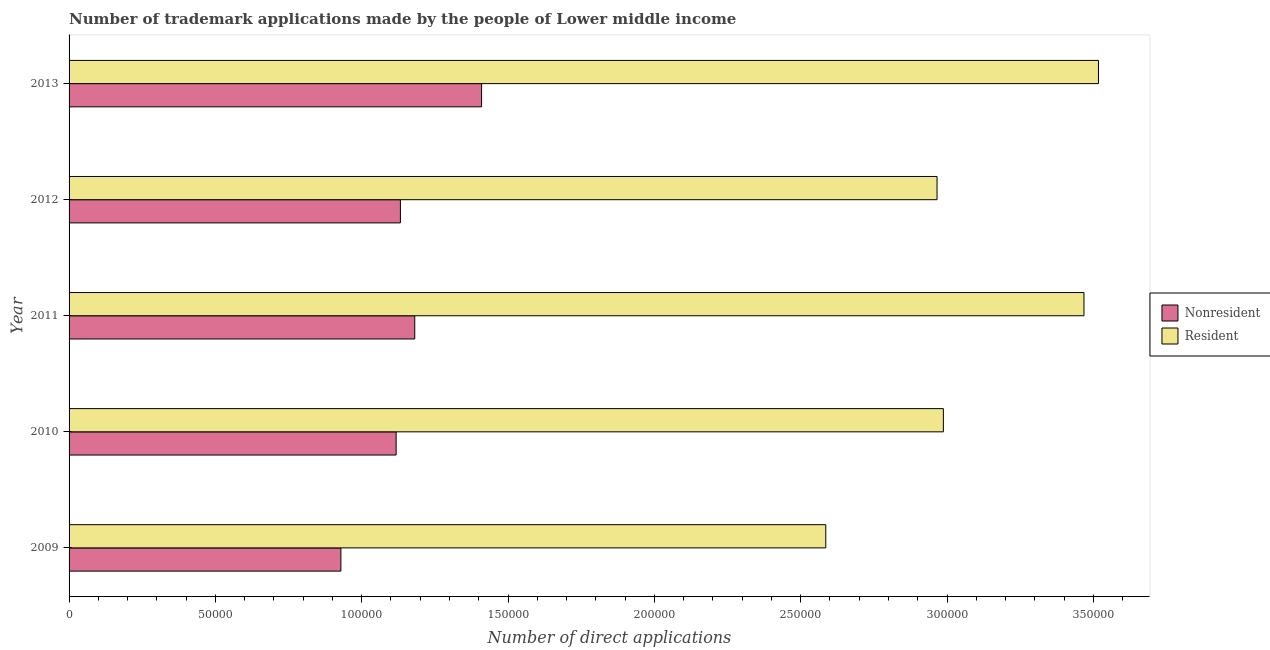How many different coloured bars are there?
Offer a very short reply. 2. Are the number of bars per tick equal to the number of legend labels?
Provide a short and direct response. Yes. Are the number of bars on each tick of the Y-axis equal?
Provide a succinct answer. Yes. How many bars are there on the 3rd tick from the top?
Give a very brief answer. 2. How many bars are there on the 2nd tick from the bottom?
Your answer should be very brief. 2. What is the label of the 4th group of bars from the top?
Keep it short and to the point. 2010. In how many cases, is the number of bars for a given year not equal to the number of legend labels?
Make the answer very short. 0. What is the number of trademark applications made by residents in 2013?
Your answer should be compact. 3.52e+05. Across all years, what is the maximum number of trademark applications made by non residents?
Ensure brevity in your answer.  1.41e+05. Across all years, what is the minimum number of trademark applications made by residents?
Your answer should be compact. 2.59e+05. In which year was the number of trademark applications made by non residents maximum?
Make the answer very short. 2013. What is the total number of trademark applications made by residents in the graph?
Your response must be concise. 1.55e+06. What is the difference between the number of trademark applications made by non residents in 2010 and that in 2012?
Offer a very short reply. -1458. What is the difference between the number of trademark applications made by non residents in 2009 and the number of trademark applications made by residents in 2010?
Offer a very short reply. -2.06e+05. What is the average number of trademark applications made by residents per year?
Keep it short and to the point. 3.10e+05. In the year 2010, what is the difference between the number of trademark applications made by residents and number of trademark applications made by non residents?
Ensure brevity in your answer.  1.87e+05. In how many years, is the number of trademark applications made by residents greater than 280000 ?
Your response must be concise. 4. What is the ratio of the number of trademark applications made by residents in 2009 to that in 2011?
Your answer should be compact. 0.75. Is the number of trademark applications made by residents in 2009 less than that in 2011?
Give a very brief answer. Yes. Is the difference between the number of trademark applications made by non residents in 2010 and 2012 greater than the difference between the number of trademark applications made by residents in 2010 and 2012?
Your answer should be very brief. No. What is the difference between the highest and the second highest number of trademark applications made by residents?
Your answer should be compact. 4956. What is the difference between the highest and the lowest number of trademark applications made by non residents?
Your response must be concise. 4.81e+04. In how many years, is the number of trademark applications made by non residents greater than the average number of trademark applications made by non residents taken over all years?
Your response must be concise. 2. Is the sum of the number of trademark applications made by non residents in 2009 and 2011 greater than the maximum number of trademark applications made by residents across all years?
Your answer should be very brief. No. What does the 1st bar from the top in 2010 represents?
Your answer should be very brief. Resident. What does the 2nd bar from the bottom in 2011 represents?
Your answer should be very brief. Resident. How many bars are there?
Make the answer very short. 10. Are all the bars in the graph horizontal?
Offer a terse response. Yes. How many years are there in the graph?
Give a very brief answer. 5. How are the legend labels stacked?
Make the answer very short. Vertical. What is the title of the graph?
Ensure brevity in your answer.  Number of trademark applications made by the people of Lower middle income. Does "Ages 15-24" appear as one of the legend labels in the graph?
Provide a short and direct response. No. What is the label or title of the X-axis?
Offer a very short reply. Number of direct applications. What is the Number of direct applications in Nonresident in 2009?
Offer a very short reply. 9.29e+04. What is the Number of direct applications of Resident in 2009?
Offer a terse response. 2.59e+05. What is the Number of direct applications of Nonresident in 2010?
Your answer should be compact. 1.12e+05. What is the Number of direct applications of Resident in 2010?
Offer a terse response. 2.99e+05. What is the Number of direct applications in Nonresident in 2011?
Keep it short and to the point. 1.18e+05. What is the Number of direct applications of Resident in 2011?
Keep it short and to the point. 3.47e+05. What is the Number of direct applications in Nonresident in 2012?
Provide a short and direct response. 1.13e+05. What is the Number of direct applications of Resident in 2012?
Ensure brevity in your answer.  2.97e+05. What is the Number of direct applications of Nonresident in 2013?
Offer a terse response. 1.41e+05. What is the Number of direct applications in Resident in 2013?
Offer a very short reply. 3.52e+05. Across all years, what is the maximum Number of direct applications of Nonresident?
Keep it short and to the point. 1.41e+05. Across all years, what is the maximum Number of direct applications in Resident?
Your answer should be compact. 3.52e+05. Across all years, what is the minimum Number of direct applications in Nonresident?
Keep it short and to the point. 9.29e+04. Across all years, what is the minimum Number of direct applications of Resident?
Provide a succinct answer. 2.59e+05. What is the total Number of direct applications of Nonresident in the graph?
Your response must be concise. 5.77e+05. What is the total Number of direct applications in Resident in the graph?
Ensure brevity in your answer.  1.55e+06. What is the difference between the Number of direct applications of Nonresident in 2009 and that in 2010?
Offer a terse response. -1.89e+04. What is the difference between the Number of direct applications in Resident in 2009 and that in 2010?
Offer a terse response. -4.02e+04. What is the difference between the Number of direct applications in Nonresident in 2009 and that in 2011?
Ensure brevity in your answer.  -2.52e+04. What is the difference between the Number of direct applications in Resident in 2009 and that in 2011?
Provide a succinct answer. -8.82e+04. What is the difference between the Number of direct applications of Nonresident in 2009 and that in 2012?
Your answer should be compact. -2.03e+04. What is the difference between the Number of direct applications of Resident in 2009 and that in 2012?
Make the answer very short. -3.80e+04. What is the difference between the Number of direct applications of Nonresident in 2009 and that in 2013?
Give a very brief answer. -4.81e+04. What is the difference between the Number of direct applications of Resident in 2009 and that in 2013?
Keep it short and to the point. -9.32e+04. What is the difference between the Number of direct applications of Nonresident in 2010 and that in 2011?
Make the answer very short. -6363. What is the difference between the Number of direct applications in Resident in 2010 and that in 2011?
Make the answer very short. -4.80e+04. What is the difference between the Number of direct applications of Nonresident in 2010 and that in 2012?
Give a very brief answer. -1458. What is the difference between the Number of direct applications of Resident in 2010 and that in 2012?
Provide a succinct answer. 2166. What is the difference between the Number of direct applications of Nonresident in 2010 and that in 2013?
Offer a terse response. -2.92e+04. What is the difference between the Number of direct applications of Resident in 2010 and that in 2013?
Keep it short and to the point. -5.30e+04. What is the difference between the Number of direct applications of Nonresident in 2011 and that in 2012?
Your response must be concise. 4905. What is the difference between the Number of direct applications in Resident in 2011 and that in 2012?
Offer a terse response. 5.02e+04. What is the difference between the Number of direct applications in Nonresident in 2011 and that in 2013?
Offer a very short reply. -2.28e+04. What is the difference between the Number of direct applications in Resident in 2011 and that in 2013?
Provide a succinct answer. -4956. What is the difference between the Number of direct applications of Nonresident in 2012 and that in 2013?
Give a very brief answer. -2.77e+04. What is the difference between the Number of direct applications of Resident in 2012 and that in 2013?
Keep it short and to the point. -5.52e+04. What is the difference between the Number of direct applications of Nonresident in 2009 and the Number of direct applications of Resident in 2010?
Make the answer very short. -2.06e+05. What is the difference between the Number of direct applications of Nonresident in 2009 and the Number of direct applications of Resident in 2011?
Give a very brief answer. -2.54e+05. What is the difference between the Number of direct applications of Nonresident in 2009 and the Number of direct applications of Resident in 2012?
Offer a very short reply. -2.04e+05. What is the difference between the Number of direct applications of Nonresident in 2009 and the Number of direct applications of Resident in 2013?
Make the answer very short. -2.59e+05. What is the difference between the Number of direct applications in Nonresident in 2010 and the Number of direct applications in Resident in 2011?
Keep it short and to the point. -2.35e+05. What is the difference between the Number of direct applications of Nonresident in 2010 and the Number of direct applications of Resident in 2012?
Provide a succinct answer. -1.85e+05. What is the difference between the Number of direct applications in Nonresident in 2010 and the Number of direct applications in Resident in 2013?
Provide a short and direct response. -2.40e+05. What is the difference between the Number of direct applications in Nonresident in 2011 and the Number of direct applications in Resident in 2012?
Your answer should be very brief. -1.78e+05. What is the difference between the Number of direct applications of Nonresident in 2011 and the Number of direct applications of Resident in 2013?
Make the answer very short. -2.34e+05. What is the difference between the Number of direct applications in Nonresident in 2012 and the Number of direct applications in Resident in 2013?
Ensure brevity in your answer.  -2.39e+05. What is the average Number of direct applications in Nonresident per year?
Give a very brief answer. 1.15e+05. What is the average Number of direct applications of Resident per year?
Ensure brevity in your answer.  3.10e+05. In the year 2009, what is the difference between the Number of direct applications of Nonresident and Number of direct applications of Resident?
Your answer should be compact. -1.66e+05. In the year 2010, what is the difference between the Number of direct applications of Nonresident and Number of direct applications of Resident?
Your answer should be compact. -1.87e+05. In the year 2011, what is the difference between the Number of direct applications in Nonresident and Number of direct applications in Resident?
Make the answer very short. -2.29e+05. In the year 2012, what is the difference between the Number of direct applications in Nonresident and Number of direct applications in Resident?
Ensure brevity in your answer.  -1.83e+05. In the year 2013, what is the difference between the Number of direct applications of Nonresident and Number of direct applications of Resident?
Provide a succinct answer. -2.11e+05. What is the ratio of the Number of direct applications of Nonresident in 2009 to that in 2010?
Make the answer very short. 0.83. What is the ratio of the Number of direct applications in Resident in 2009 to that in 2010?
Provide a short and direct response. 0.87. What is the ratio of the Number of direct applications in Nonresident in 2009 to that in 2011?
Your answer should be very brief. 0.79. What is the ratio of the Number of direct applications in Resident in 2009 to that in 2011?
Your answer should be compact. 0.75. What is the ratio of the Number of direct applications in Nonresident in 2009 to that in 2012?
Offer a very short reply. 0.82. What is the ratio of the Number of direct applications of Resident in 2009 to that in 2012?
Give a very brief answer. 0.87. What is the ratio of the Number of direct applications of Nonresident in 2009 to that in 2013?
Offer a terse response. 0.66. What is the ratio of the Number of direct applications in Resident in 2009 to that in 2013?
Provide a short and direct response. 0.74. What is the ratio of the Number of direct applications of Nonresident in 2010 to that in 2011?
Ensure brevity in your answer.  0.95. What is the ratio of the Number of direct applications of Resident in 2010 to that in 2011?
Provide a short and direct response. 0.86. What is the ratio of the Number of direct applications in Nonresident in 2010 to that in 2012?
Offer a very short reply. 0.99. What is the ratio of the Number of direct applications in Resident in 2010 to that in 2012?
Your answer should be very brief. 1.01. What is the ratio of the Number of direct applications in Nonresident in 2010 to that in 2013?
Your answer should be compact. 0.79. What is the ratio of the Number of direct applications in Resident in 2010 to that in 2013?
Give a very brief answer. 0.85. What is the ratio of the Number of direct applications in Nonresident in 2011 to that in 2012?
Keep it short and to the point. 1.04. What is the ratio of the Number of direct applications in Resident in 2011 to that in 2012?
Ensure brevity in your answer.  1.17. What is the ratio of the Number of direct applications in Nonresident in 2011 to that in 2013?
Your answer should be very brief. 0.84. What is the ratio of the Number of direct applications of Resident in 2011 to that in 2013?
Offer a very short reply. 0.99. What is the ratio of the Number of direct applications in Nonresident in 2012 to that in 2013?
Provide a short and direct response. 0.8. What is the ratio of the Number of direct applications in Resident in 2012 to that in 2013?
Your response must be concise. 0.84. What is the difference between the highest and the second highest Number of direct applications of Nonresident?
Keep it short and to the point. 2.28e+04. What is the difference between the highest and the second highest Number of direct applications in Resident?
Provide a succinct answer. 4956. What is the difference between the highest and the lowest Number of direct applications in Nonresident?
Provide a succinct answer. 4.81e+04. What is the difference between the highest and the lowest Number of direct applications in Resident?
Make the answer very short. 9.32e+04. 